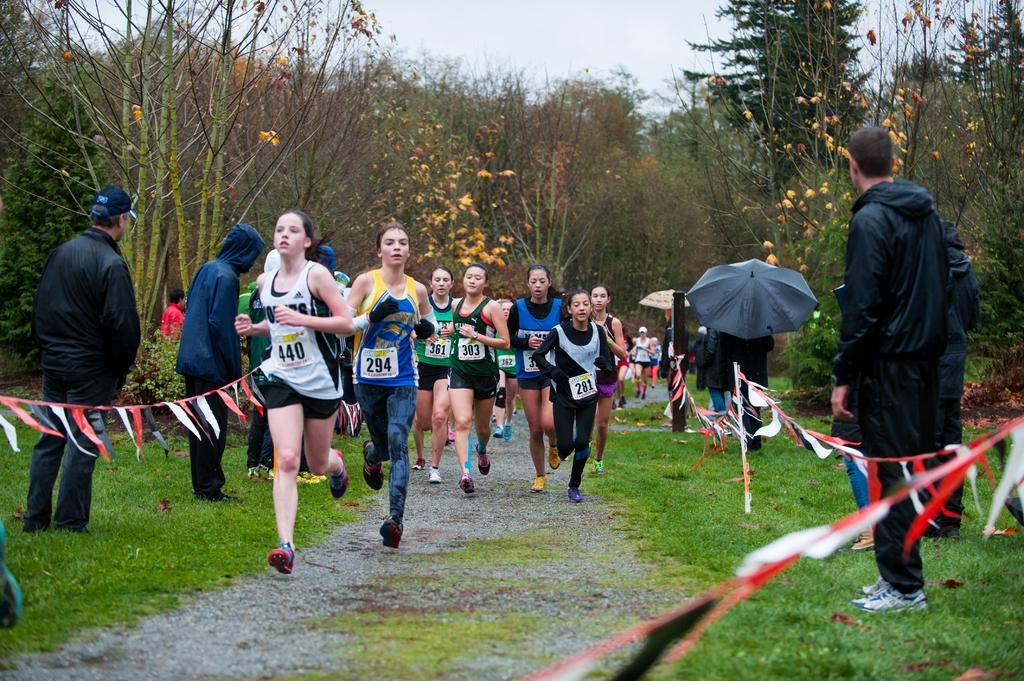What is the main subject of the image? The main subject of the image is a group of girls. What are the girls doing in the image? The girls are running. What can be seen at the top of the image? The sky is visible at the top of the image. What degree of poison is present in the image? There is no mention of poison in the image, so it cannot be determined if any degree of poison is present. 